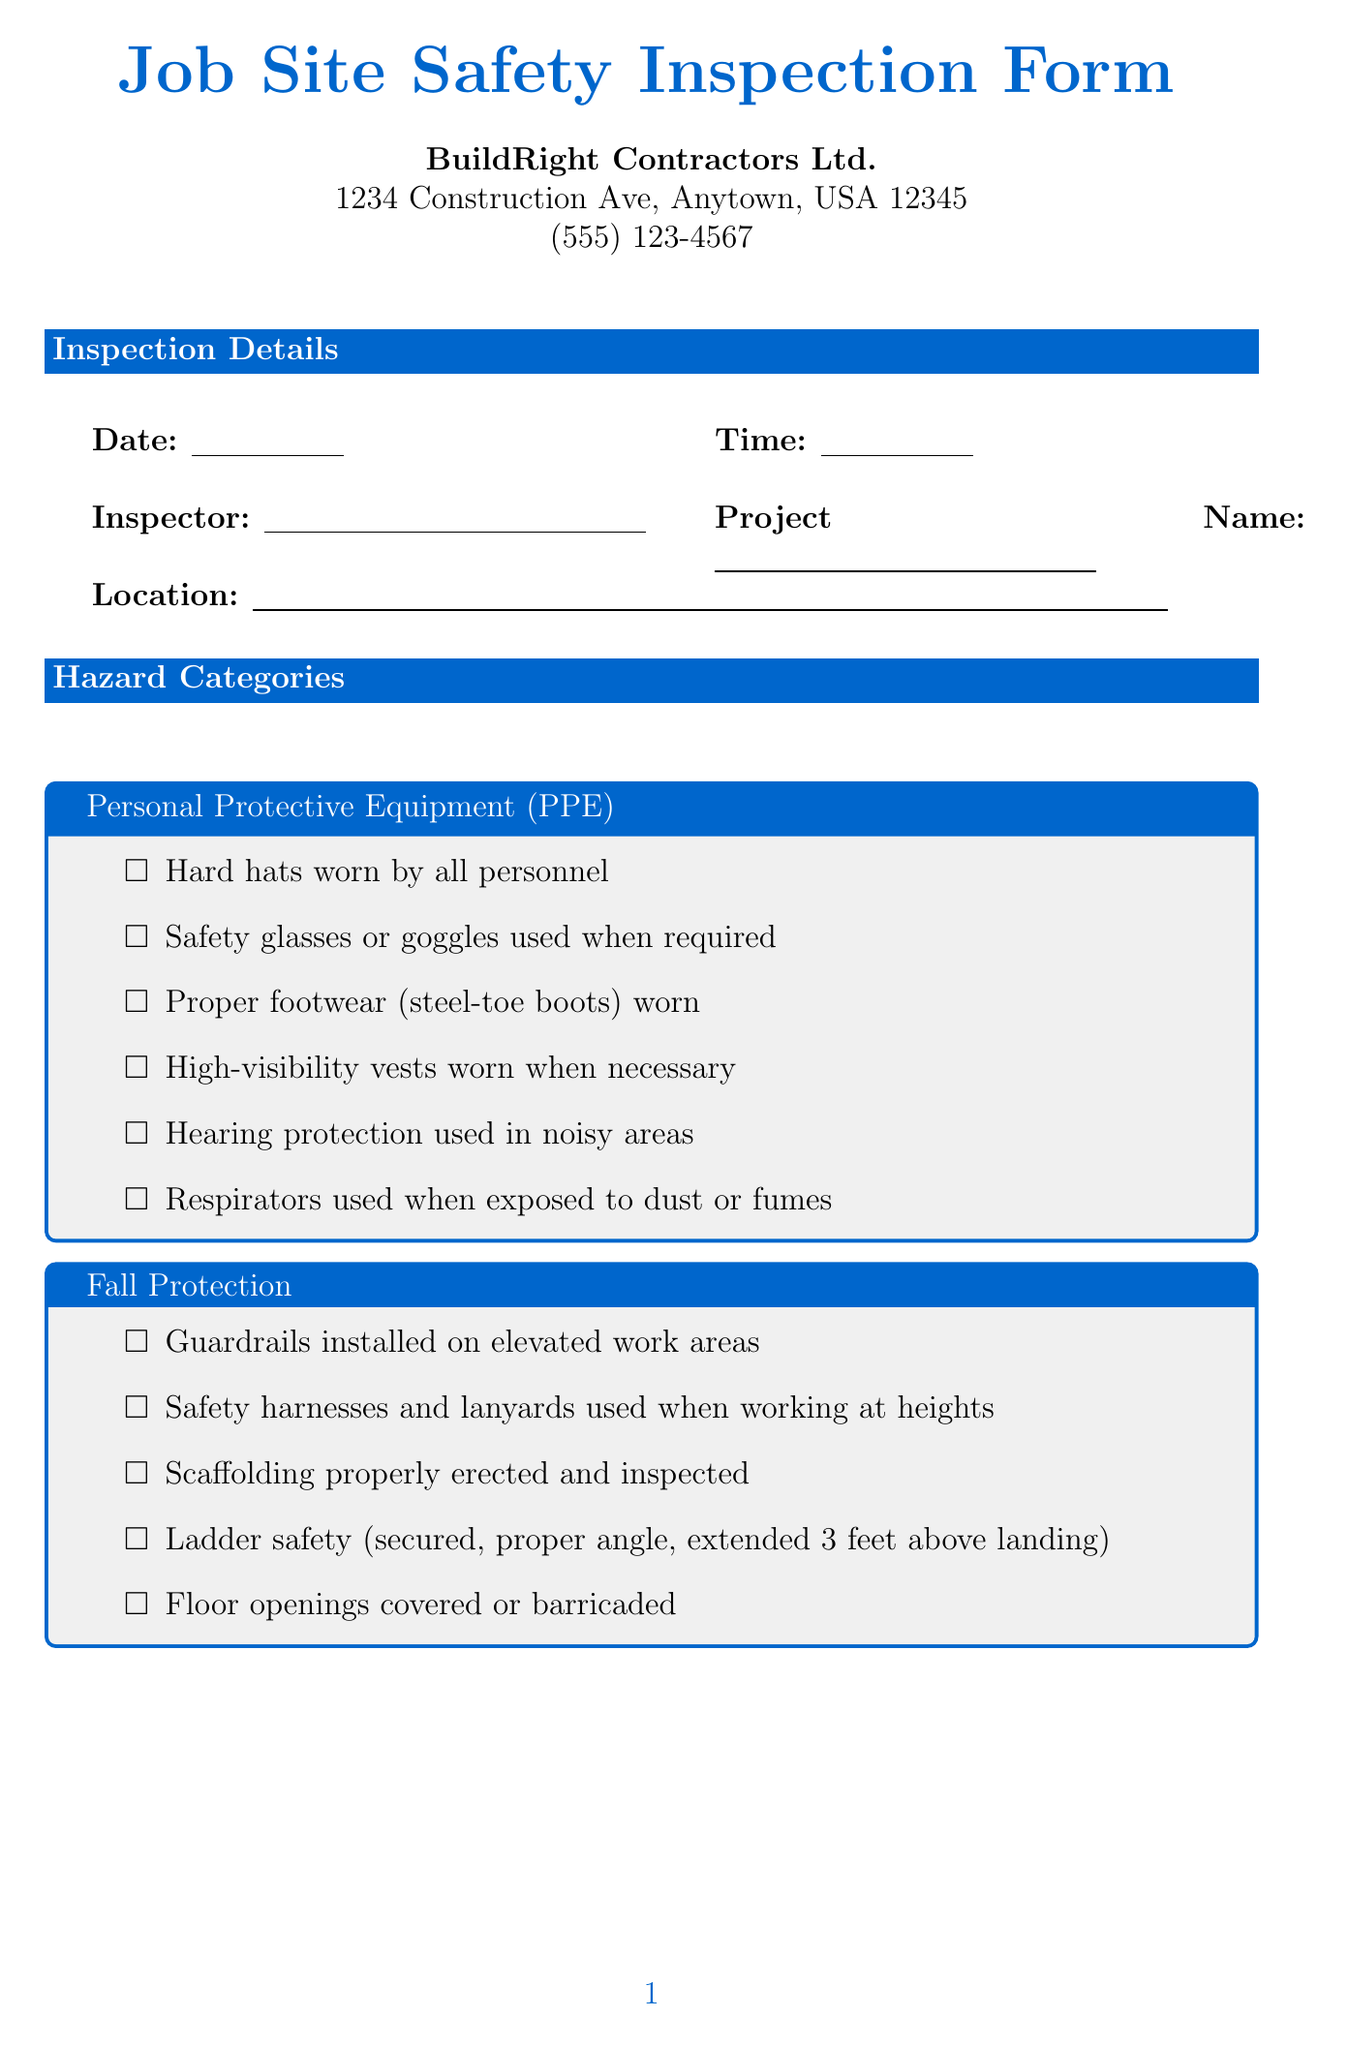What is the name of the company? The company name is listed at the top of the form under company information.
Answer: BuildRight Contractors Ltd What is the inspector's signature field? The signature section specifically labels the inspector's signature.
Answer: Inspector Signature What date is suggested for the follow-up inspection? The follow-up inspection date is provided in the follow-up inspection section of the form.
Answer: YYYY-MM-DD Which category includes fire extinguishers? This category is discussed under the list of hazard categories related to fire safety.
Answer: Fire Prevention What should be worn by all personnel according to PPE recommendations? The PPE category lists required equipment for safety on the job site.
Answer: Hard hats worn by all personnel What is the target date for corrective actions? The target date is specified in the hazard identification table for addressing identified hazards.
Answer: YYYY-MM-DD How many total hazard categories are listed? The document contains a structured list of safety categories for review.
Answer: Six What is the name of the person responsible for corrective actions? The responsible person's name is a specified field in the hazard identification section.
Answer: Name Which safety measures are to be followed in the Electrical Safety category? Safety measures related to electrical safety are listed under that specific category heading.
Answer: GFCI protection for all power tools and cords 